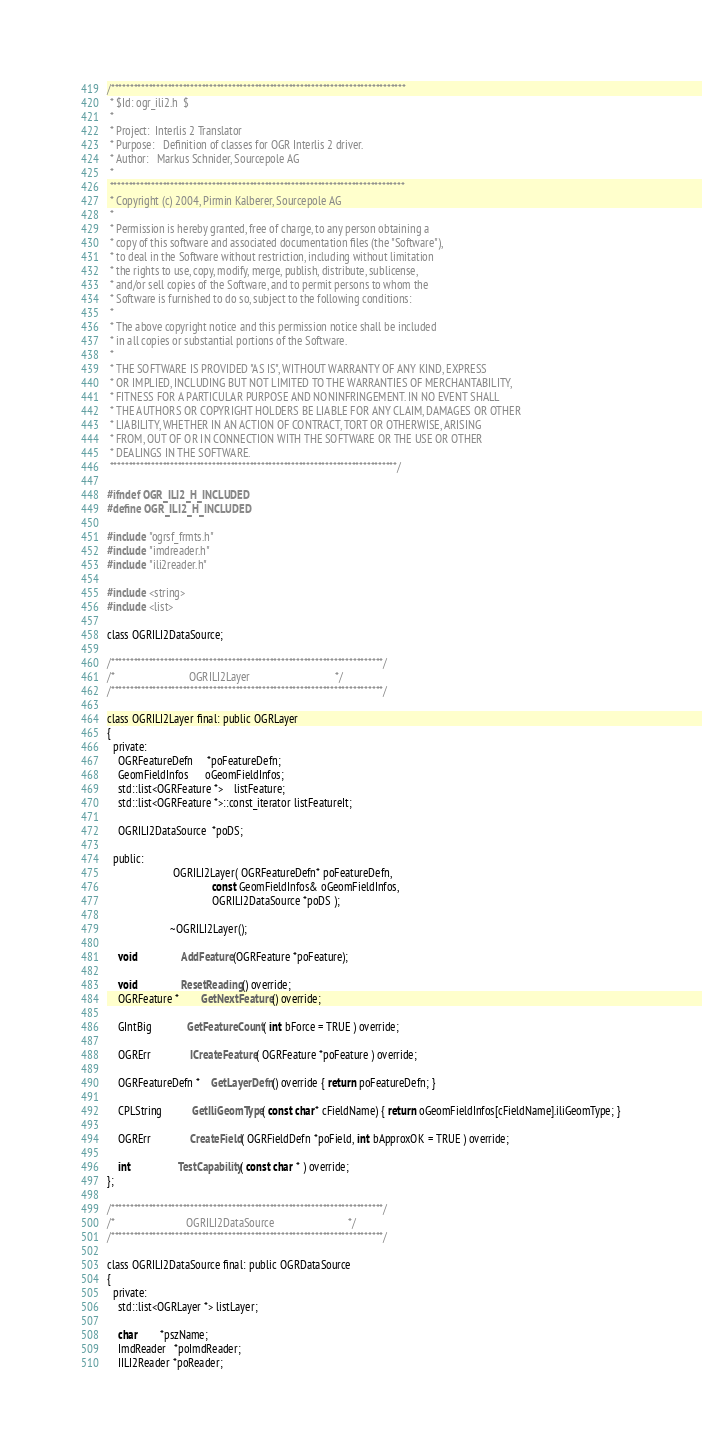Convert code to text. <code><loc_0><loc_0><loc_500><loc_500><_C_>/******************************************************************************
 * $Id: ogr_ili2.h  $
 *
 * Project:  Interlis 2 Translator
 * Purpose:   Definition of classes for OGR Interlis 2 driver.
 * Author:   Markus Schnider, Sourcepole AG
 *
 ******************************************************************************
 * Copyright (c) 2004, Pirmin Kalberer, Sourcepole AG
 *
 * Permission is hereby granted, free of charge, to any person obtaining a
 * copy of this software and associated documentation files (the "Software"),
 * to deal in the Software without restriction, including without limitation
 * the rights to use, copy, modify, merge, publish, distribute, sublicense,
 * and/or sell copies of the Software, and to permit persons to whom the
 * Software is furnished to do so, subject to the following conditions:
 *
 * The above copyright notice and this permission notice shall be included
 * in all copies or substantial portions of the Software.
 *
 * THE SOFTWARE IS PROVIDED "AS IS", WITHOUT WARRANTY OF ANY KIND, EXPRESS
 * OR IMPLIED, INCLUDING BUT NOT LIMITED TO THE WARRANTIES OF MERCHANTABILITY,
 * FITNESS FOR A PARTICULAR PURPOSE AND NONINFRINGEMENT. IN NO EVENT SHALL
 * THE AUTHORS OR COPYRIGHT HOLDERS BE LIABLE FOR ANY CLAIM, DAMAGES OR OTHER
 * LIABILITY, WHETHER IN AN ACTION OF CONTRACT, TORT OR OTHERWISE, ARISING
 * FROM, OUT OF OR IN CONNECTION WITH THE SOFTWARE OR THE USE OR OTHER
 * DEALINGS IN THE SOFTWARE.
 ****************************************************************************/

#ifndef OGR_ILI2_H_INCLUDED
#define OGR_ILI2_H_INCLUDED

#include "ogrsf_frmts.h"
#include "imdreader.h"
#include "ili2reader.h"

#include <string>
#include <list>

class OGRILI2DataSource;

/************************************************************************/
/*                           OGRILI2Layer                               */
/************************************************************************/

class OGRILI2Layer final: public OGRLayer
{
  private:
    OGRFeatureDefn     *poFeatureDefn;
    GeomFieldInfos      oGeomFieldInfos;
    std::list<OGRFeature *>    listFeature;
    std::list<OGRFeature *>::const_iterator listFeatureIt;

    OGRILI2DataSource  *poDS;

  public:
                        OGRILI2Layer( OGRFeatureDefn* poFeatureDefn,
                                      const GeomFieldInfos& oGeomFieldInfos,
                                      OGRILI2DataSource *poDS );

                       ~OGRILI2Layer();

    void                AddFeature(OGRFeature *poFeature);

    void                ResetReading() override;
    OGRFeature *        GetNextFeature() override;

    GIntBig             GetFeatureCount( int bForce = TRUE ) override;

    OGRErr              ICreateFeature( OGRFeature *poFeature ) override;

    OGRFeatureDefn *    GetLayerDefn() override { return poFeatureDefn; }

    CPLString           GetIliGeomType( const char* cFieldName) { return oGeomFieldInfos[cFieldName].iliGeomType; }

    OGRErr              CreateField( OGRFieldDefn *poField, int bApproxOK = TRUE ) override;

    int                 TestCapability( const char * ) override;
};

/************************************************************************/
/*                          OGRILI2DataSource                           */
/************************************************************************/

class OGRILI2DataSource final: public OGRDataSource
{
  private:
    std::list<OGRLayer *> listLayer;

    char        *pszName;
    ImdReader   *poImdReader;
    IILI2Reader *poReader;</code> 